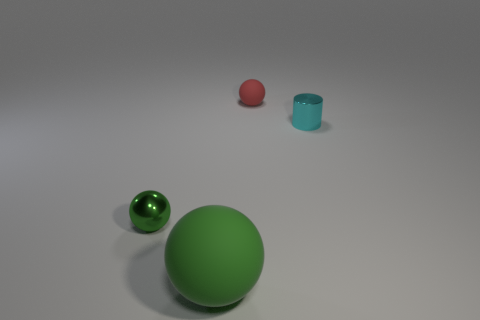Is there any other thing that has the same size as the green rubber sphere?
Your answer should be very brief. No. Do the metal thing in front of the tiny cyan object and the ball that is behind the tiny cylinder have the same color?
Your answer should be compact. No. Are there more tiny balls than big green matte spheres?
Make the answer very short. Yes. What number of large objects have the same color as the shiny sphere?
Ensure brevity in your answer.  1. What is the color of the other matte object that is the same shape as the big thing?
Give a very brief answer. Red. There is a ball that is behind the green rubber thing and on the right side of the green metallic thing; what is it made of?
Your answer should be very brief. Rubber. Does the small sphere that is to the left of the large thing have the same material as the tiny red ball that is on the right side of the tiny green metallic sphere?
Your answer should be very brief. No. What size is the green rubber sphere?
Provide a short and direct response. Large. What is the size of the other green object that is the same shape as the tiny green shiny thing?
Offer a very short reply. Large. There is a small cyan metal cylinder; how many small cyan metal cylinders are on the right side of it?
Ensure brevity in your answer.  0. 